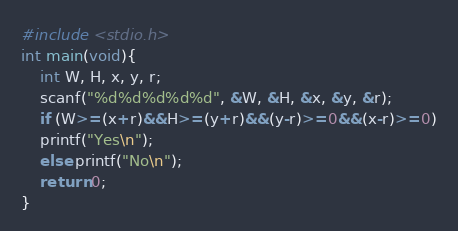<code> <loc_0><loc_0><loc_500><loc_500><_C_>#include <stdio.h>
int main(void){
	int W, H, x, y, r;
	scanf("%d%d%d%d%d", &W, &H, &x, &y, &r);
	if (W>=(x+r)&&H>=(y+r)&&(y-r)>=0&&(x-r)>=0)
	printf("Yes\n");
	else printf("No\n");
	return 0;
} 
</code> 